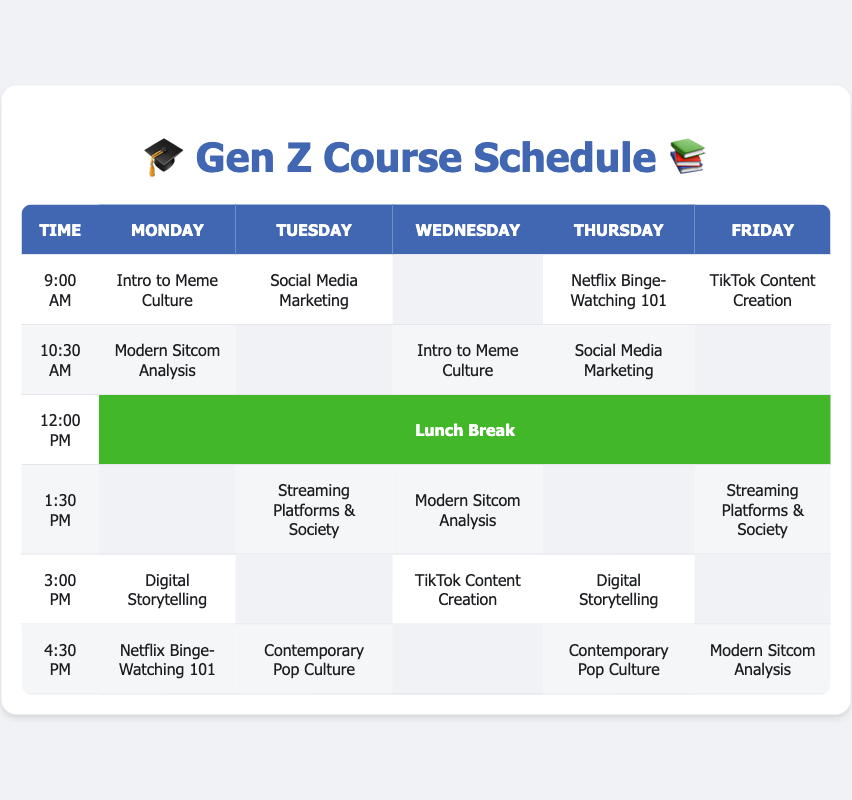What class is scheduled at 9:00 AM on Wednesday? The table shows that at 9:00 AM on Wednesday, there is no class listed, as indicated by the empty cell in that column.
Answer: No class Which two classes overlap on Thursday at 10:30 AM? Both "Social Media Marketing" and "Netflix Binge-Watching 101" are scheduled at 10:30 AM on Thursday.
Answer: Social Media Marketing and Netflix Binge-Watching 101 How many classes are offered on Monday? By counting the non-empty cells under the Monday column, there are four classes: "Intro to Meme Culture," "Modern Sitcom Analysis," "Digital Storytelling," and "Netflix Binge-Watching 101."
Answer: 4 Is there a class at 1:30 PM on Friday? The table shows that there is a class scheduled on Friday at 1:30 PM, which is "Streaming Platforms & Society."
Answer: Yes What class is taught twice in the week? Upon examining the schedule, "Social Media Marketing" and "Modern Sitcom Analysis" appear twice in the week, while the rest appear only once.
Answer: Social Media Marketing and Modern Sitcom Analysis How many unique classes are scheduled on Friday? There are five entries: "TikTok Content Creation," "Streaming Platforms & Society," "Digital Storytelling," "Modern Sitcom Analysis," and "Contemporary Pop Culture," which gives a total of four unique classes after removing duplicates.
Answer: 4 What is the maximum number of classes scheduled at the same time on any day? By inspecting each row, on Monday at 9:00 AM, there are five classes scheduled, which returns the highest tally for any single time slot through the week, confirmed by checking each 9:00 AM entry.
Answer: 5 Do any classes have a lunch break scheduled right before them? Looking at the 1:30 PM slots, “Streaming Platforms & Society” and “Modern Sitcom Analysis” occur after the lunch break at 12:00 PM on Tuesday and Wednesday, respectively, confirming that two classes follow lunch.
Answer: Yes Which day has the most empty slots? By tallying the empty slots (shown as blank cells) in the table, Tuesday has three empty slots total, more than any other day, making it the day with the most blanks.
Answer: Tuesday 